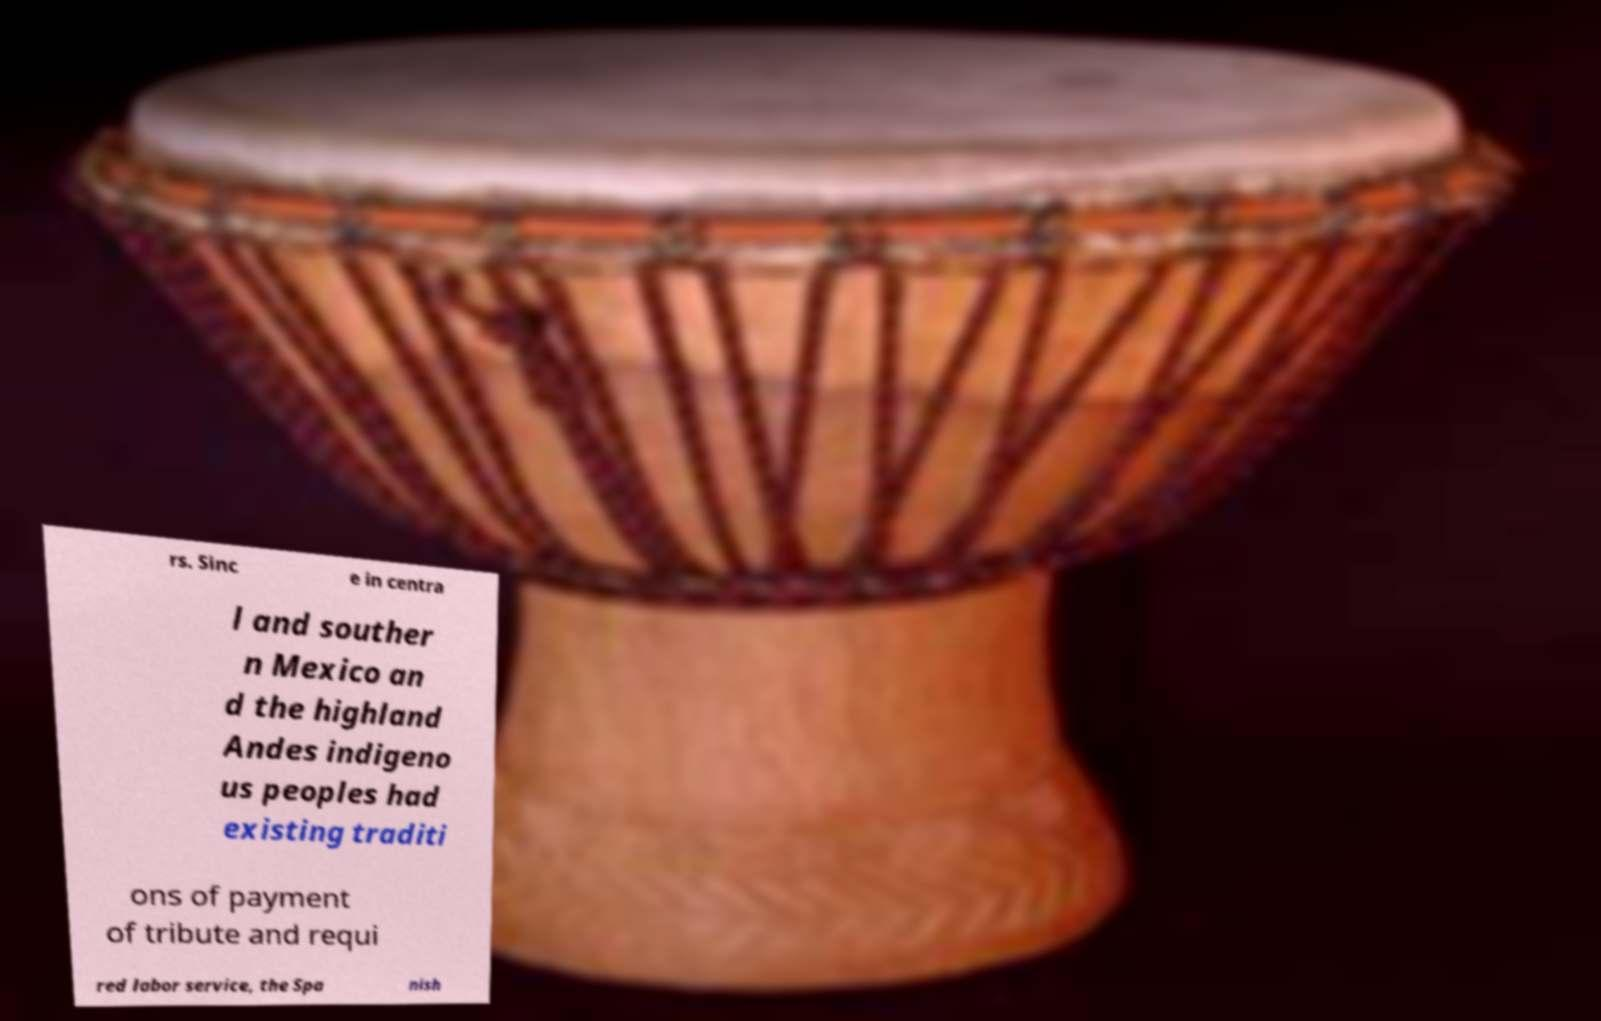For documentation purposes, I need the text within this image transcribed. Could you provide that? rs. Sinc e in centra l and souther n Mexico an d the highland Andes indigeno us peoples had existing traditi ons of payment of tribute and requi red labor service, the Spa nish 